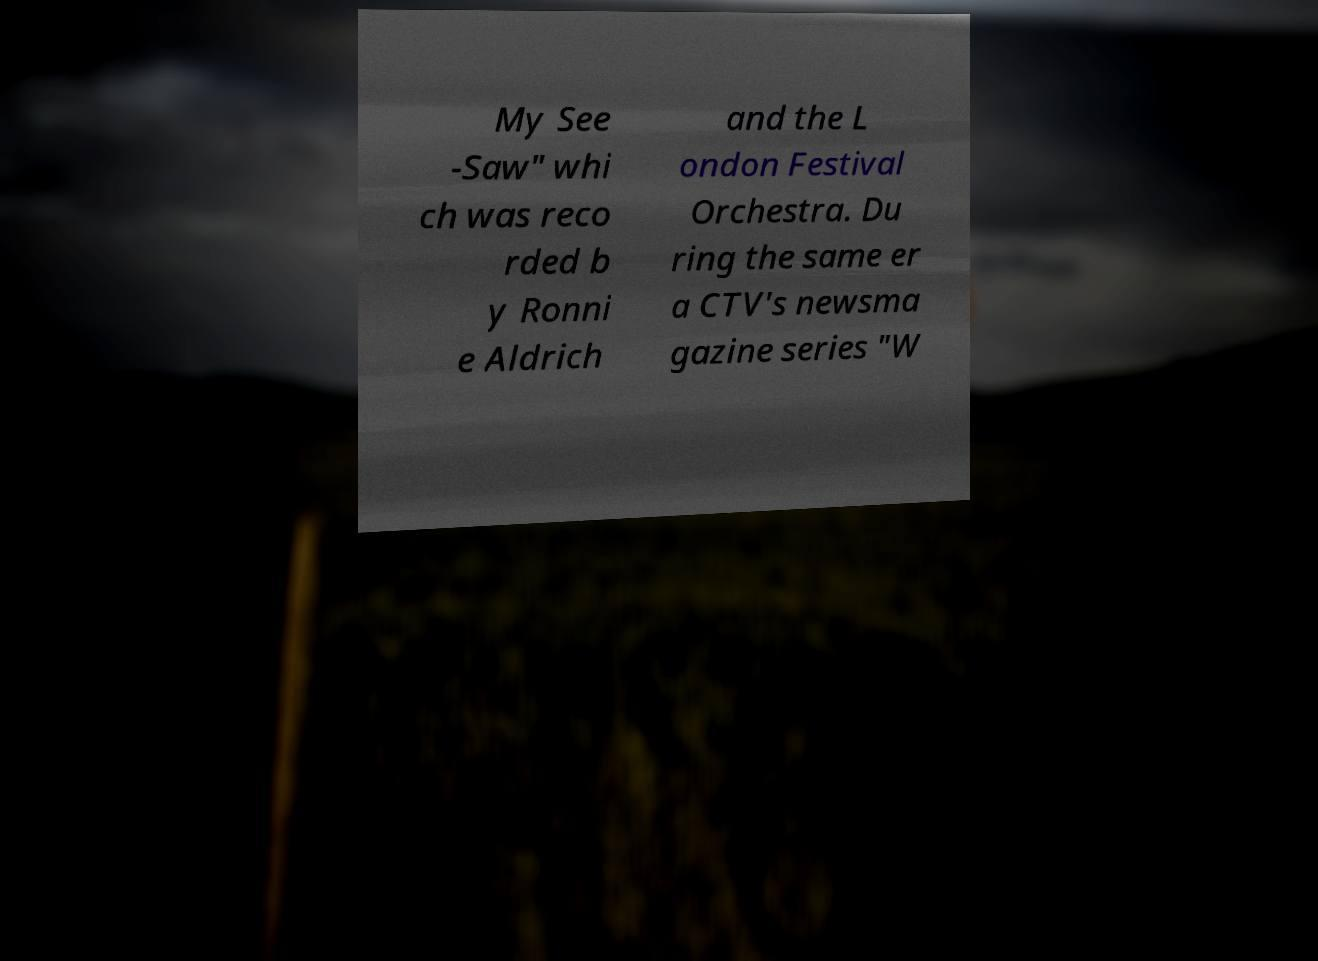Please read and relay the text visible in this image. What does it say? My See -Saw" whi ch was reco rded b y Ronni e Aldrich and the L ondon Festival Orchestra. Du ring the same er a CTV's newsma gazine series "W 